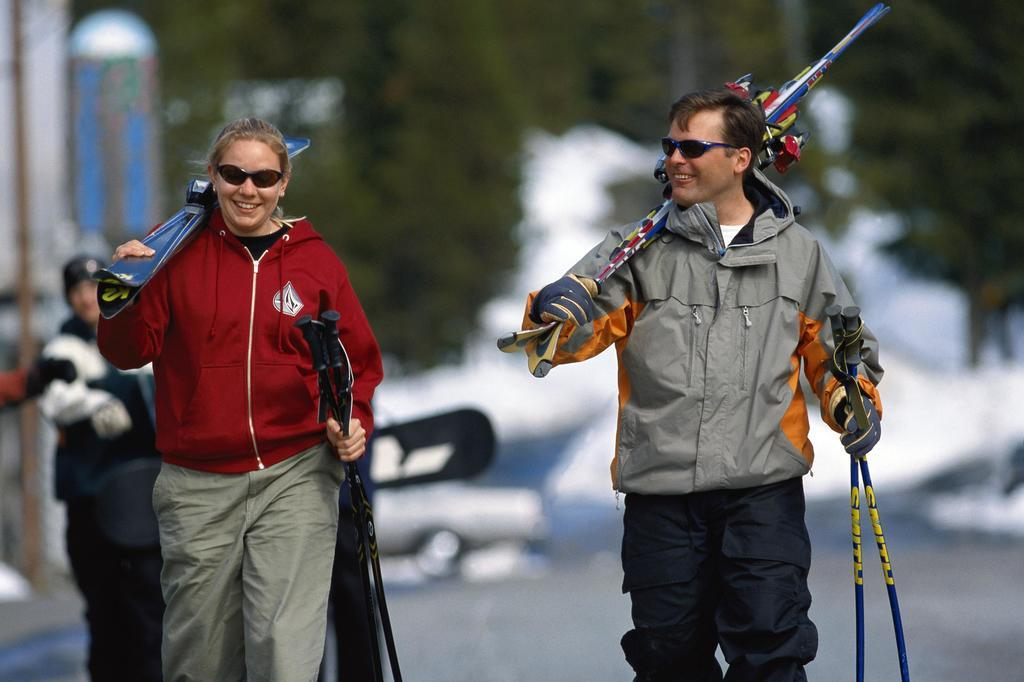How many people are present in the image? There are two persons standing in the image. What is the facial expression of the people in the image? Both persons are smiling. What are the people holding in their hands? Each person is holding something in their hand. Can you describe the third person in the image? There is a third person standing in the background of the image. How many kittens are sitting on the elbow of the person in the image? There are no kittens present in the image, and no elbows are visible. 